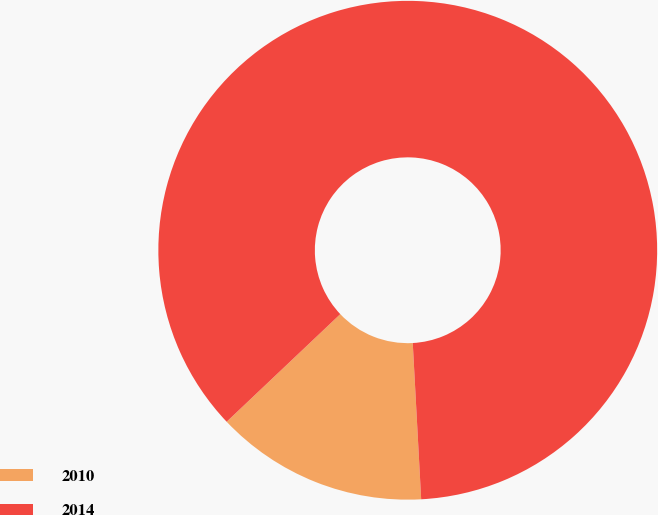<chart> <loc_0><loc_0><loc_500><loc_500><pie_chart><fcel>2010<fcel>2014<nl><fcel>13.79%<fcel>86.21%<nl></chart> 